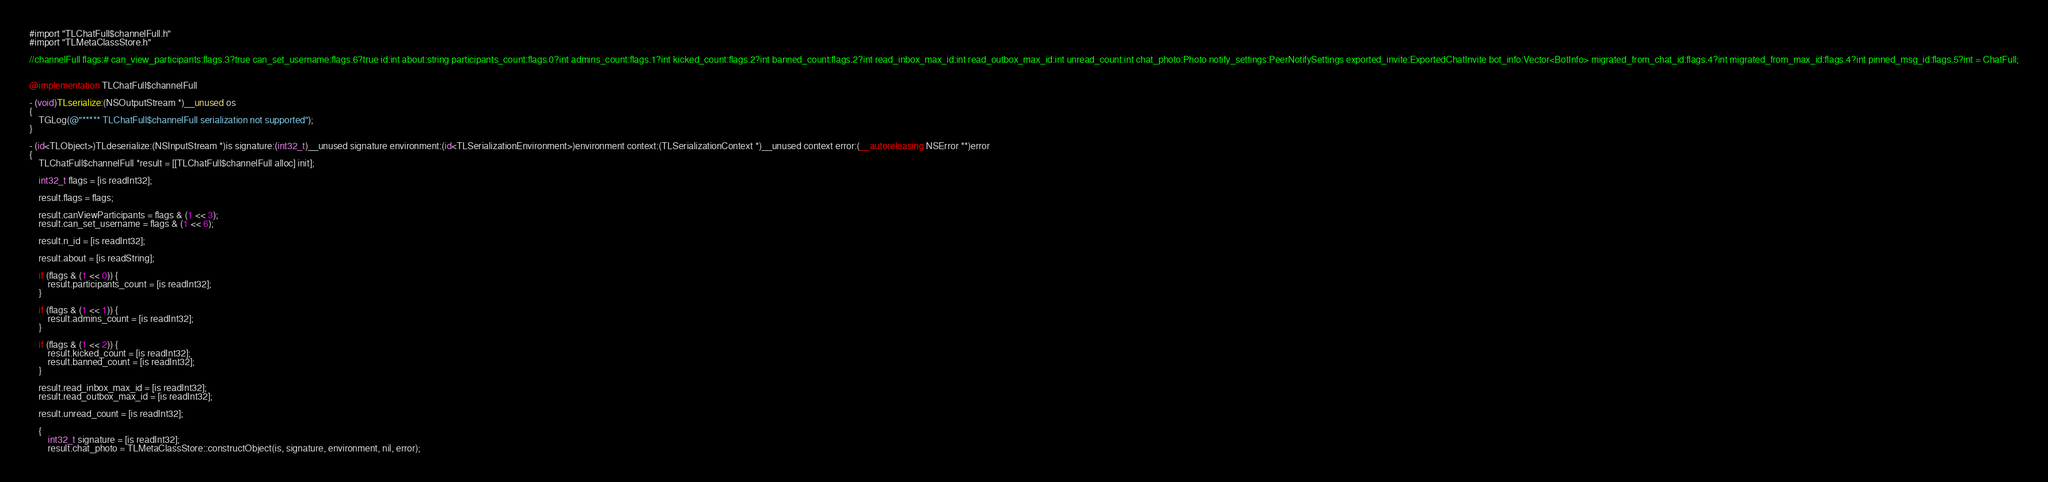Convert code to text. <code><loc_0><loc_0><loc_500><loc_500><_ObjectiveC_>#import "TLChatFull$channelFull.h"
#import "TLMetaClassStore.h"

//channelFull flags:# can_view_participants:flags.3?true can_set_username:flags.6?true id:int about:string participants_count:flags.0?int admins_count:flags.1?int kicked_count:flags.2?int banned_count:flags.2?int read_inbox_max_id:int read_outbox_max_id:int unread_count:int chat_photo:Photo notify_settings:PeerNotifySettings exported_invite:ExportedChatInvite bot_info:Vector<BotInfo> migrated_from_chat_id:flags.4?int migrated_from_max_id:flags.4?int pinned_msg_id:flags.5?int = ChatFull;


@implementation TLChatFull$channelFull

- (void)TLserialize:(NSOutputStream *)__unused os
{
    TGLog(@"***** TLChatFull$channelFull serialization not supported");
}

- (id<TLObject>)TLdeserialize:(NSInputStream *)is signature:(int32_t)__unused signature environment:(id<TLSerializationEnvironment>)environment context:(TLSerializationContext *)__unused context error:(__autoreleasing NSError **)error
{
    TLChatFull$channelFull *result = [[TLChatFull$channelFull alloc] init];
    
    int32_t flags = [is readInt32];
    
    result.flags = flags;
    
    result.canViewParticipants = flags & (1 << 3);
    result.can_set_username = flags & (1 << 6);
    
    result.n_id = [is readInt32];
    
    result.about = [is readString];
    
    if (flags & (1 << 0)) {
        result.participants_count = [is readInt32];
    }
    
    if (flags & (1 << 1)) {
        result.admins_count = [is readInt32];
    }
    
    if (flags & (1 << 2)) {
        result.kicked_count = [is readInt32];
        result.banned_count = [is readInt32];
    }
    
    result.read_inbox_max_id = [is readInt32];
    result.read_outbox_max_id = [is readInt32];
    
    result.unread_count = [is readInt32];
    
    {
        int32_t signature = [is readInt32];
        result.chat_photo = TLMetaClassStore::constructObject(is, signature, environment, nil, error);</code> 